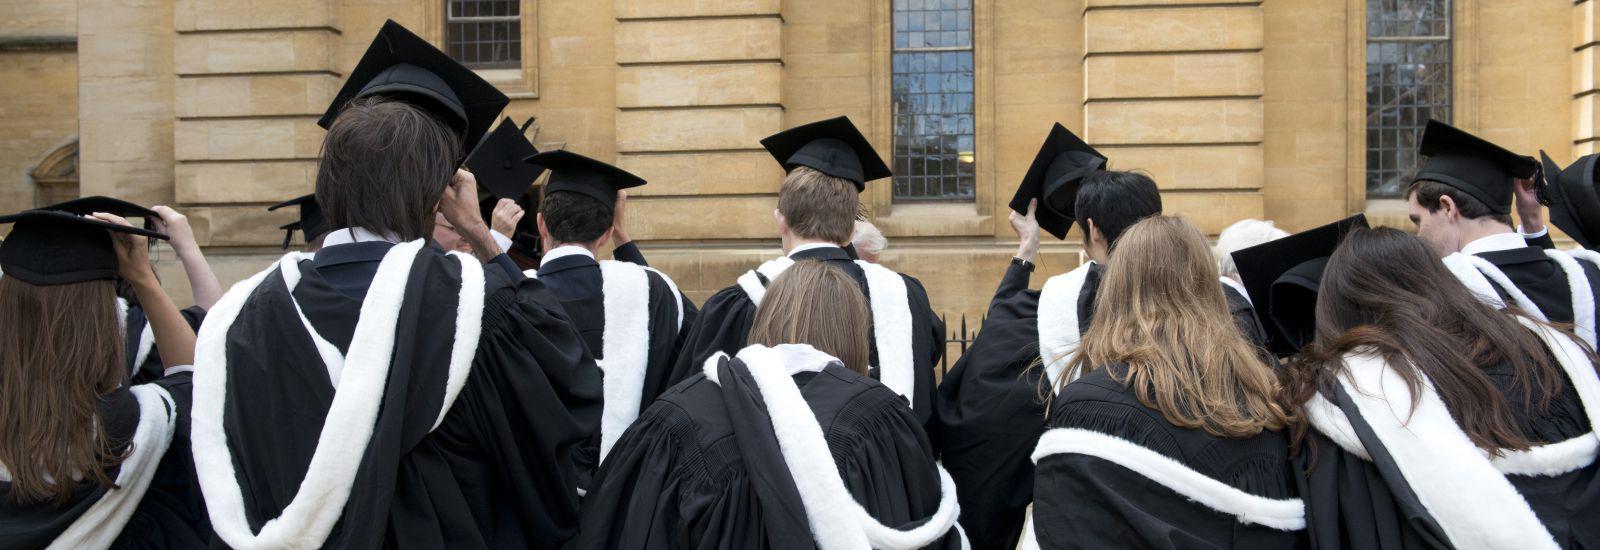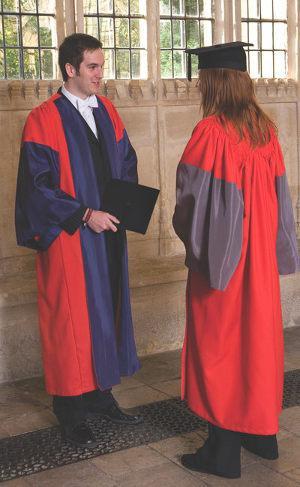The first image is the image on the left, the second image is the image on the right. For the images displayed, is the sentence "There are at most 3 graduation gowns in the image pair" factually correct? Answer yes or no. No. The first image is the image on the left, the second image is the image on the right. Assess this claim about the two images: "There is a lone woman centered in one image.". Correct or not? Answer yes or no. No. 